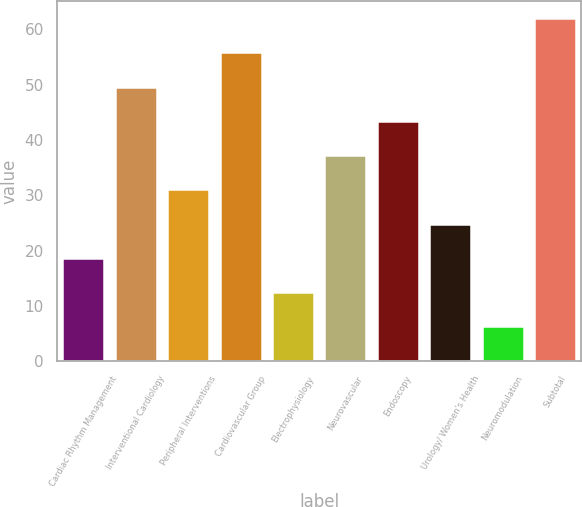<chart> <loc_0><loc_0><loc_500><loc_500><bar_chart><fcel>Cardiac Rhythm Management<fcel>Interventional Cardiology<fcel>Peripheral Interventions<fcel>Cardiovascular Group<fcel>Electrophysiology<fcel>Neurovascular<fcel>Endoscopy<fcel>Urology/ Women's Health<fcel>Neuromodulation<fcel>Subtotal<nl><fcel>18.69<fcel>49.64<fcel>31.07<fcel>55.83<fcel>12.5<fcel>37.26<fcel>43.45<fcel>24.88<fcel>6.31<fcel>62.02<nl></chart> 